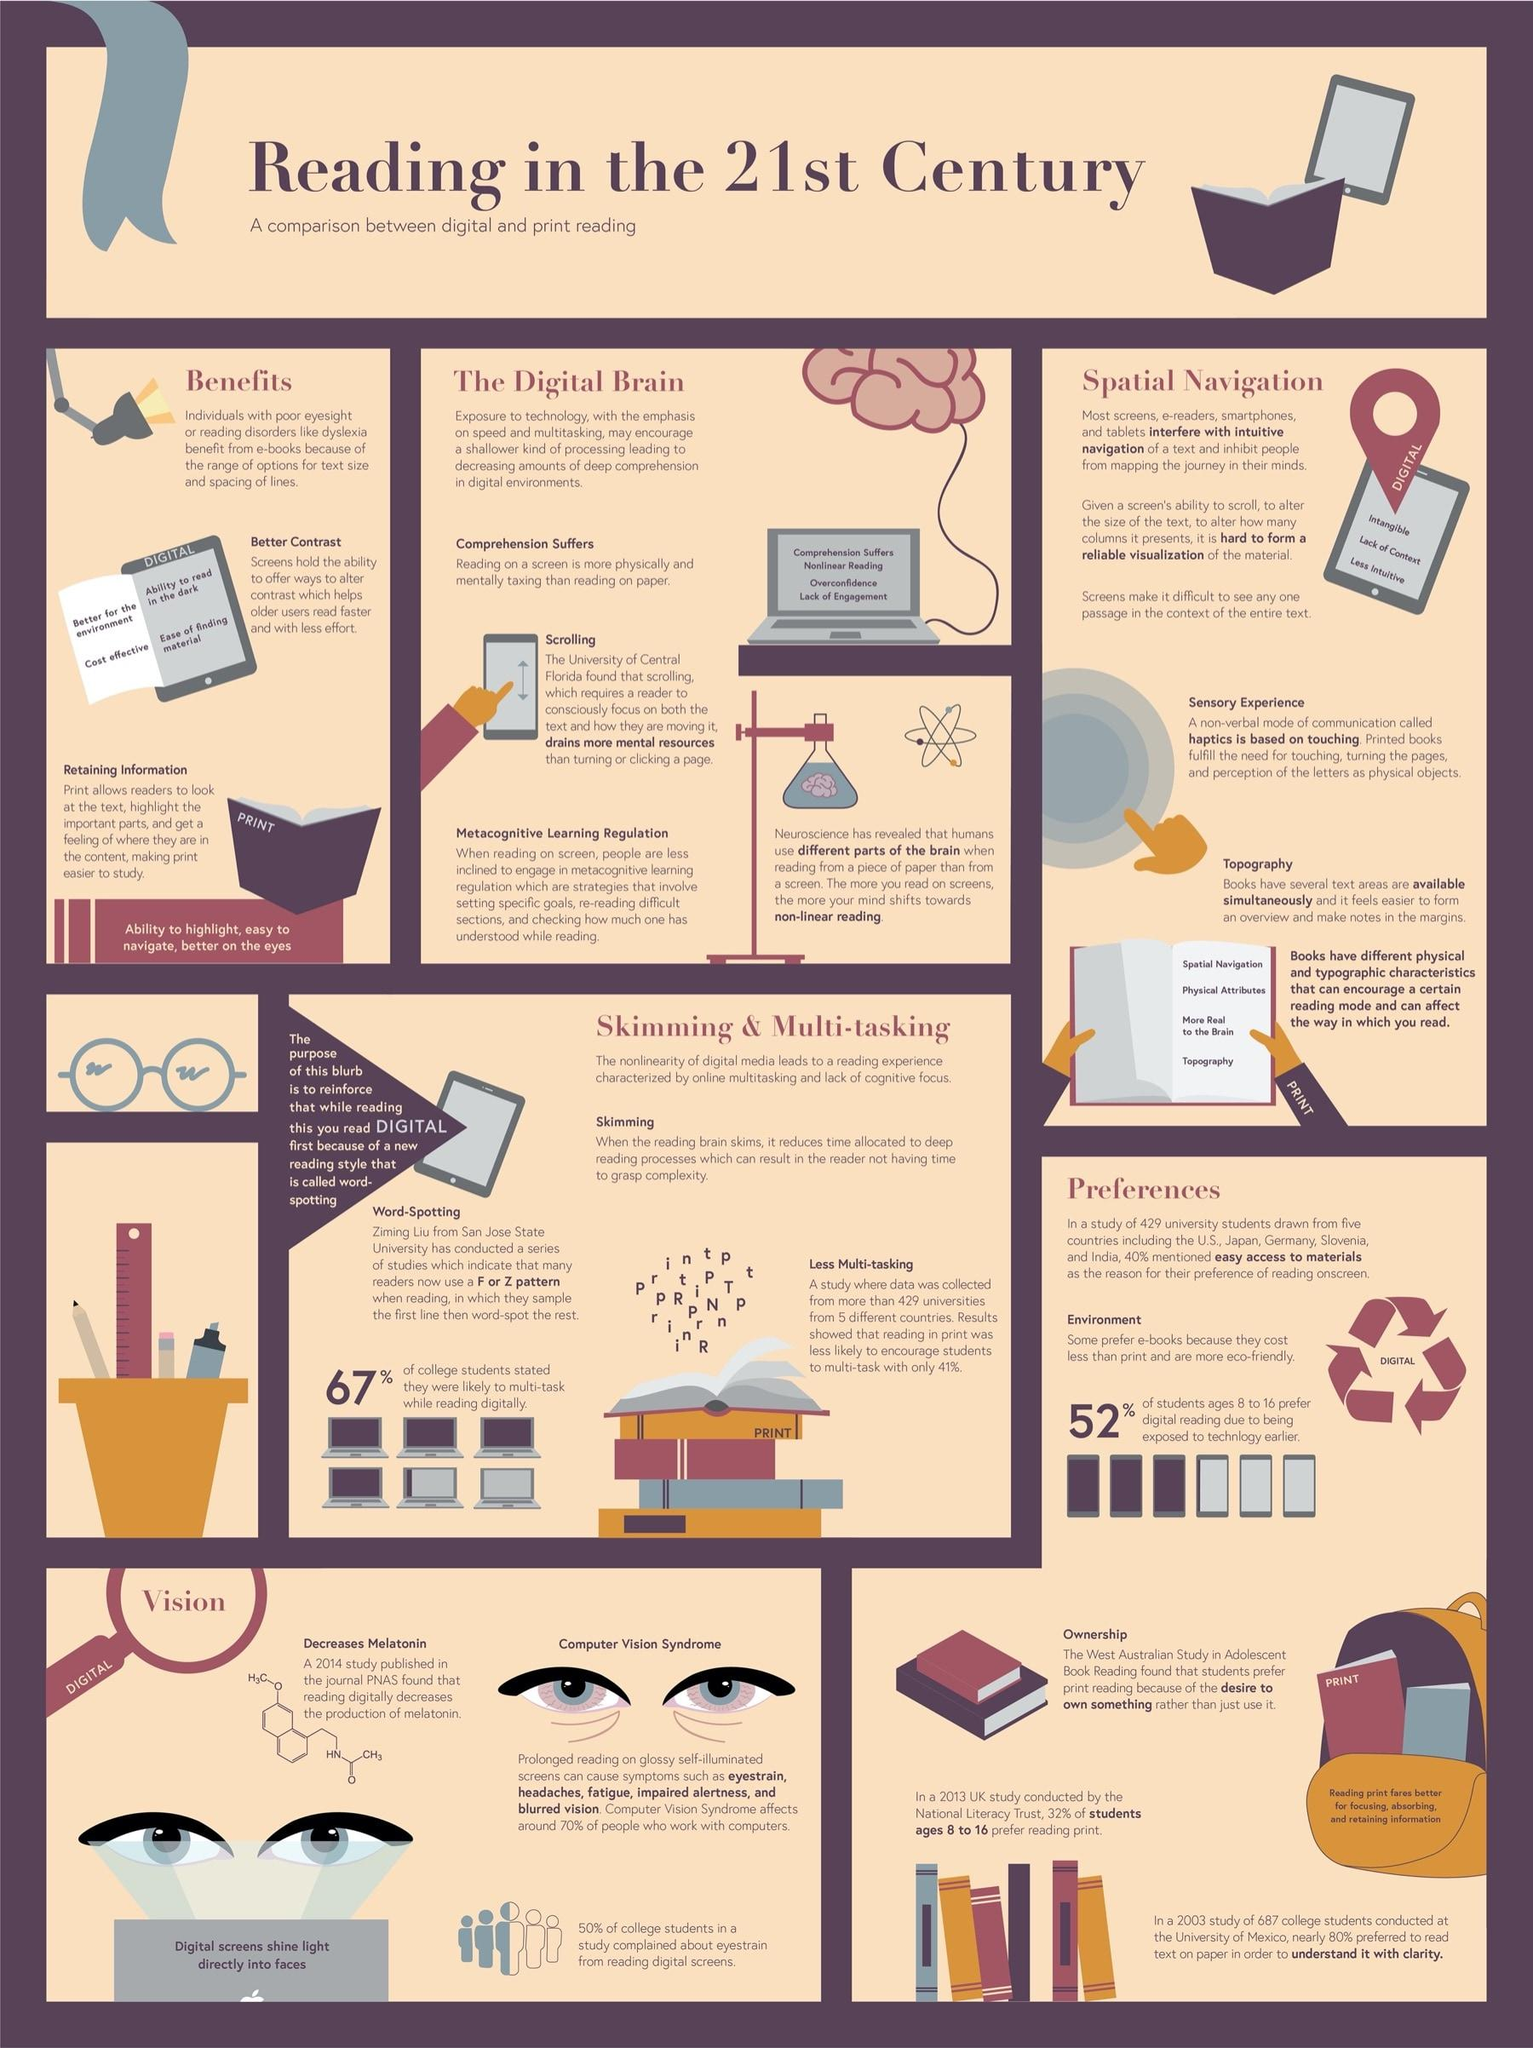Highlight a few significant elements in this photo. Digital contrast alteration is a significant benefit of reading formats. Print is more suitable for readers to retain information compared to digital formats. Digital media is preferred for being eco-friendly. It is determined that the print format is more preferable for eye comfort. The choice between the two formats, print or digital, provides a better sensory experience. 